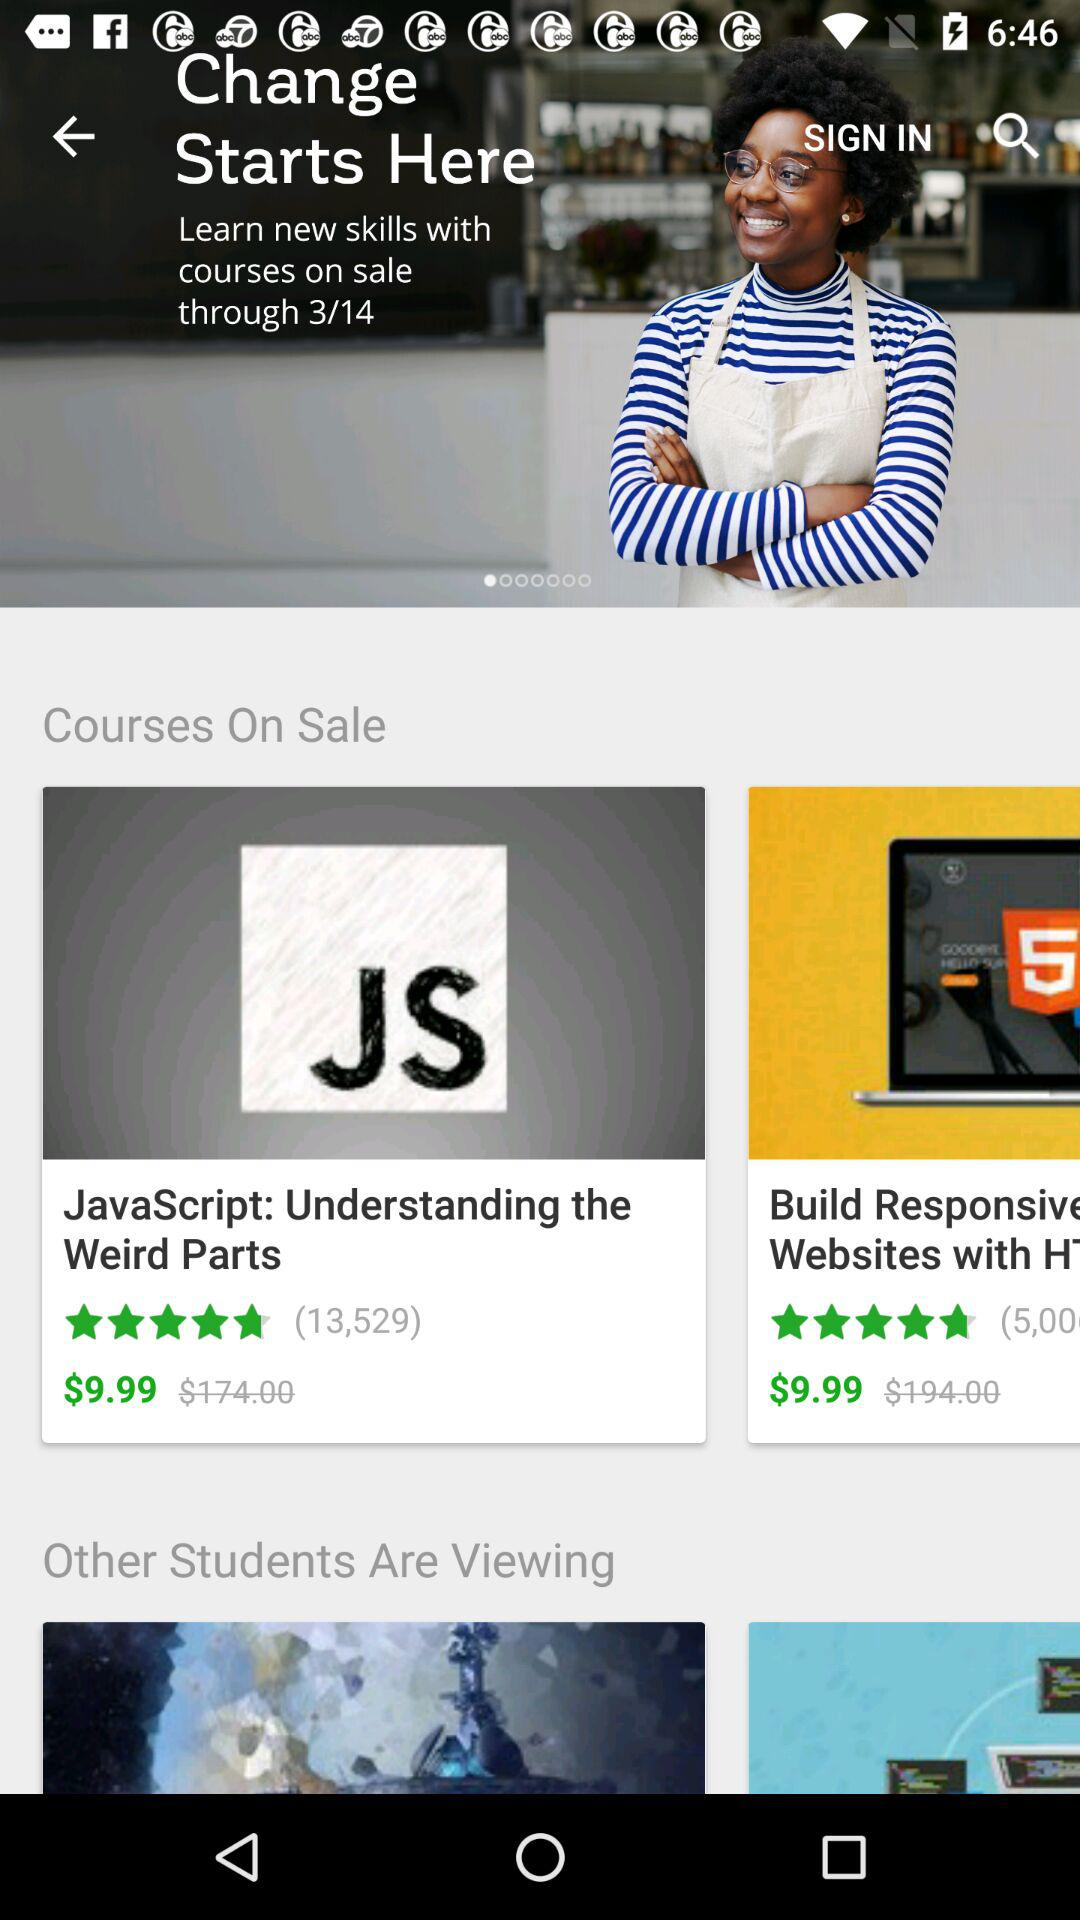What is the "JavaScript" course fee after discount? The fee for the "JavaScript" course after discount is $9.99. 